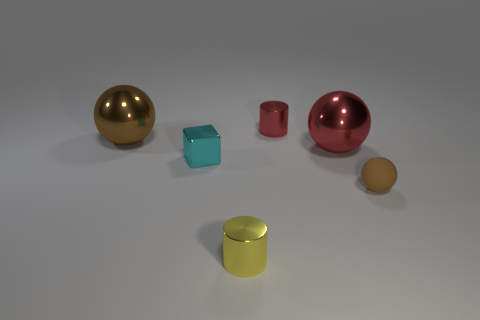Is the size of the metal cube the same as the brown shiny object?
Keep it short and to the point. No. Is there a matte thing that has the same size as the cube?
Ensure brevity in your answer.  Yes. There is a brown thing on the right side of the tiny red thing; what is its material?
Offer a very short reply. Rubber. What is the color of the big object that is made of the same material as the large brown ball?
Your answer should be very brief. Red. What number of metal objects are either gray balls or big red spheres?
Give a very brief answer. 1. There is a red metallic object that is the same size as the cyan shiny cube; what shape is it?
Offer a terse response. Cylinder. How many objects are tiny metallic cylinders in front of the tiny rubber sphere or shiny things in front of the tiny red cylinder?
Your answer should be very brief. 4. There is a brown object that is the same size as the yellow shiny object; what is it made of?
Your answer should be very brief. Rubber. How many other things are made of the same material as the large red ball?
Provide a succinct answer. 4. Are there an equal number of cylinders right of the small yellow object and cylinders in front of the brown rubber object?
Your answer should be compact. Yes. 